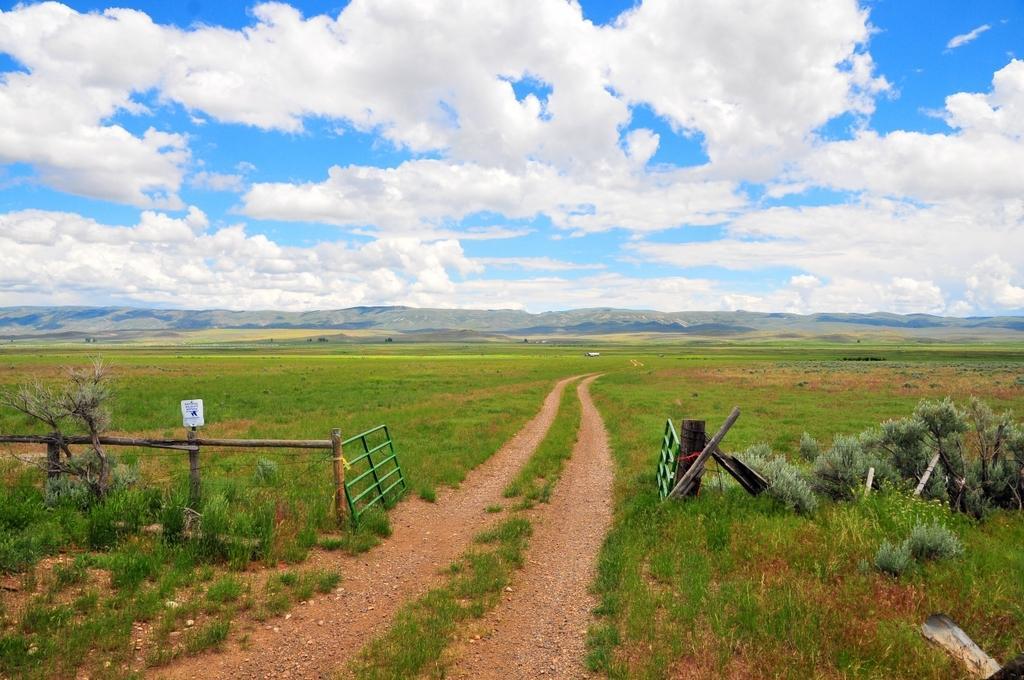Can you describe this image briefly? In this image there is fencing, gate and fields, in the background there is mountain and the sky. 